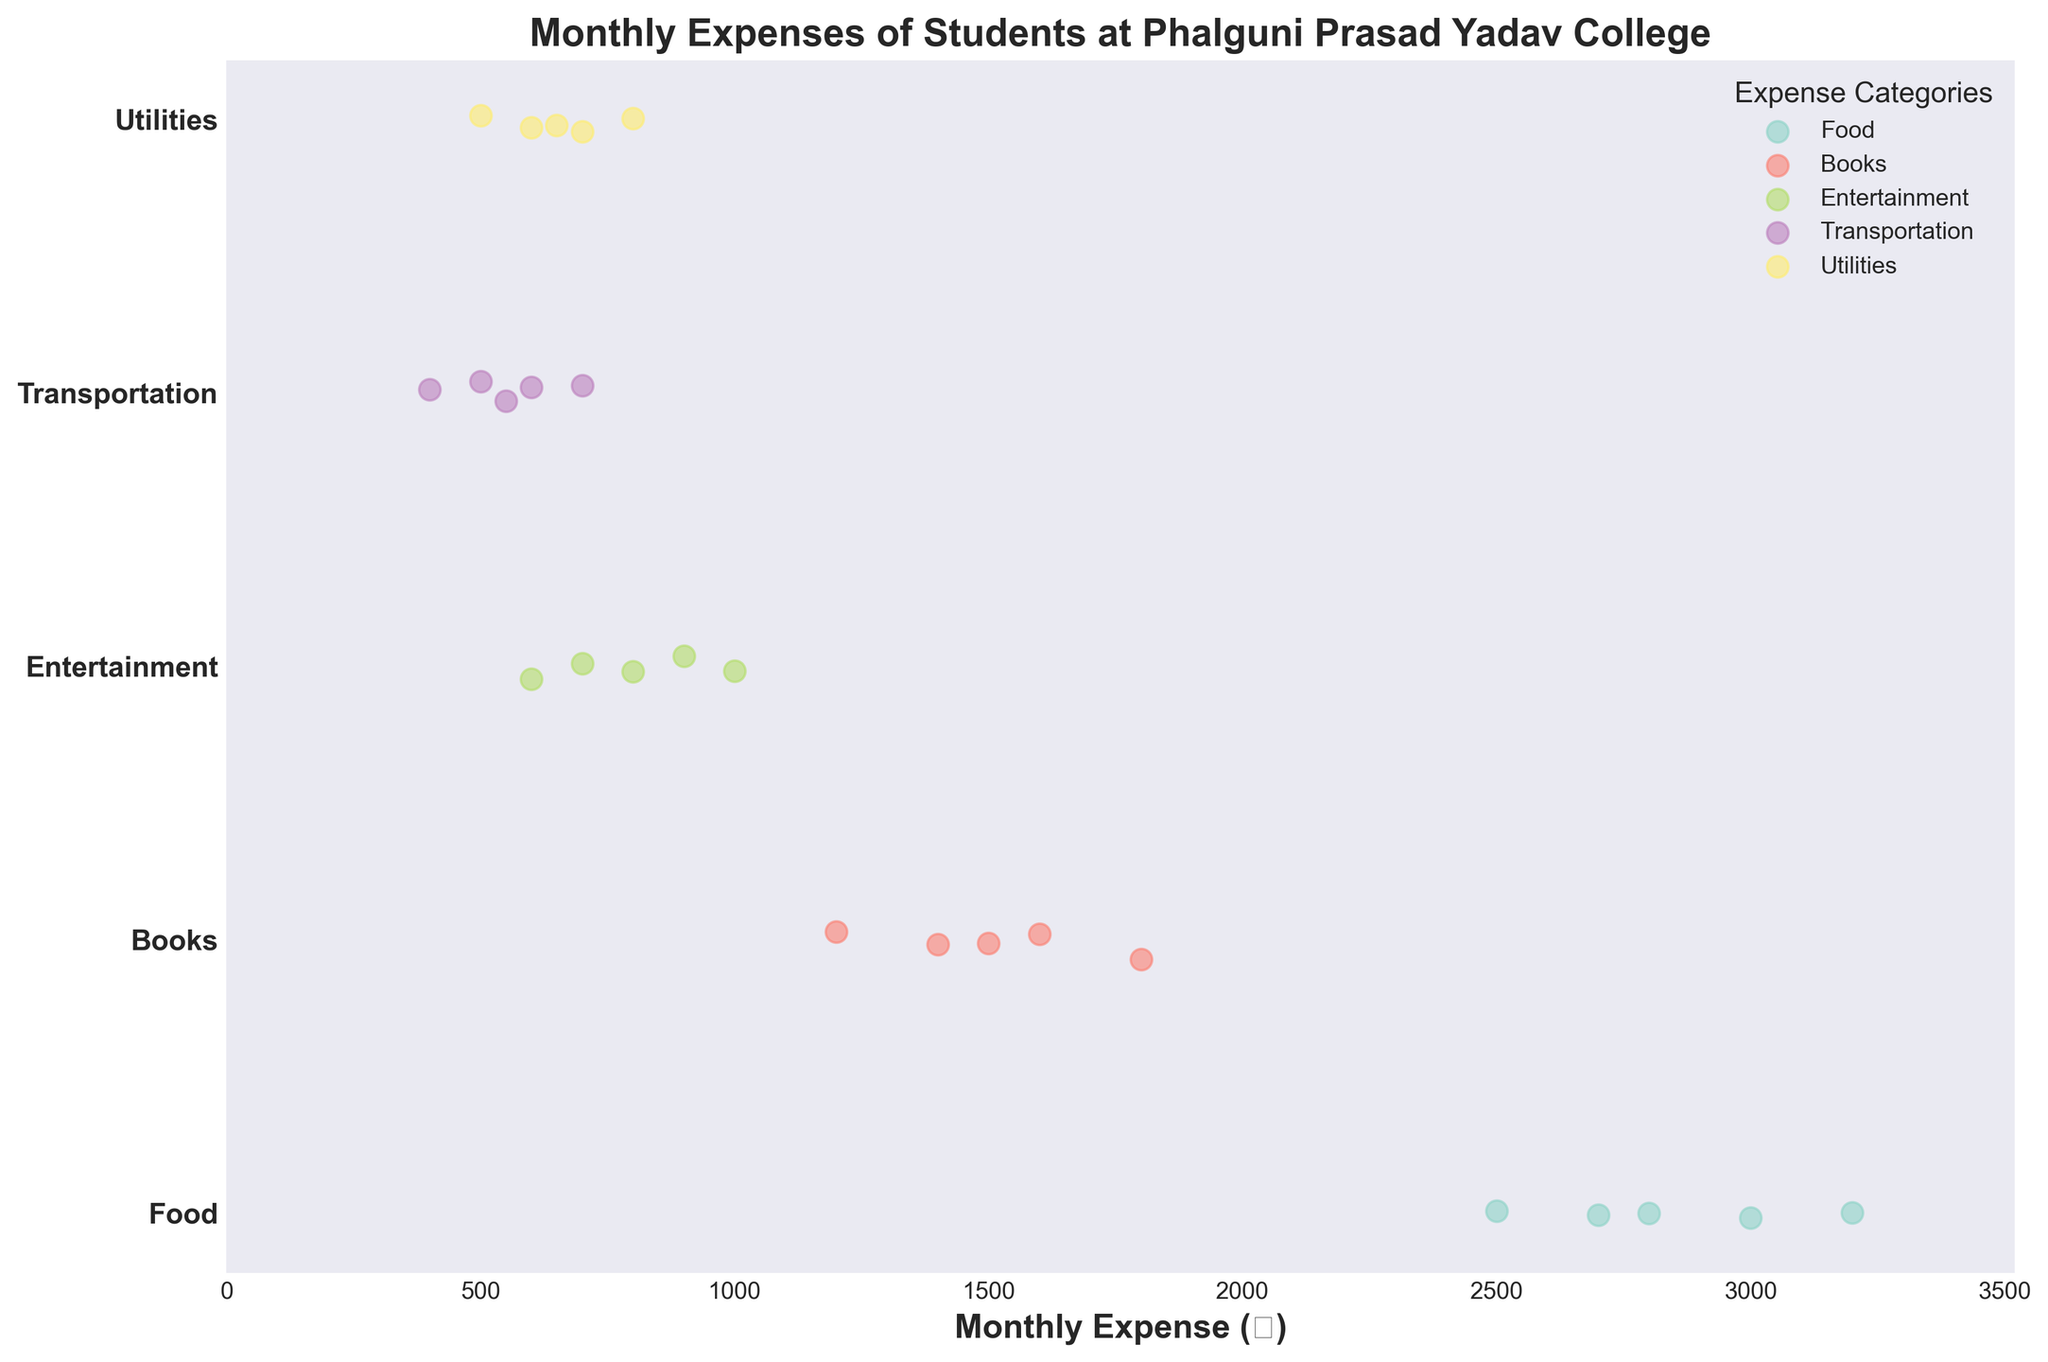What are the different categories of expenses shown in the plot? The different categories of expenses can be identified from the y-axis labels of the plot.
Answer: Food, Books, Entertainment, Transportation, Utilities What does the title of the plot indicate? The title, positioned at the top of the plot, summarises the content by mentioning the subject of the data.
Answer: Monthly Expenses of Students at Phalguni Prasad Yadav College Which category appears to have the highest expenses overall? By observing the x-axis positions of the plotted points, we can see which category's points are generally positioned further to the right, indicating higher expenses.
Answer: Food What's the range of monthly expenses for the Entertainment category? Observing the scatter points for the Entertainment category, we find the minimum and maximum x-axis values for this category. The minimum is around ₹600 and the maximum is around ₹1000.
Answer: ₹600 - ₹1000 How does the average monthly expense for Books compare to that for Transportation? To determine this, we look at the central tendency of the scatter points for these categories. The points for Books are around ₹1500, whereas for Transportation, they're around ₹550-700.
Answer: Higher for Books Which expense category has the smallest range of data points? We can identify the category with the smallest range by comparing the spread (from minimum to maximum value) of the scattered points for each category. Transportation has the smallest range from ₹400 to ₹700.
Answer: Transportation What is the approximate median monthly expense for the Food category? By observing the distribution of points for the Food category, the median would be the middle value. With data points clustered around ₹2800-3200, the median is around ₹2800-3000.
Answer: ₹2800-₹3000 Which category has points that are all below ₹700? Examining the x-axis values, the categories with all points below ₹700 are Transportation and Utilities.
Answer: Transportation, Utilities What is the monthly expense with the highest individual value in the plot? By scanning the farthest right point in any category, it appears one of the Food category points is around ₹3200.
Answer: ₹3200 Which category shows the most varied spending among students? Observing the spread of scatter points across the x-axis, the Food category shows the most varied spending, with points ranging widely around ₹2500 to ₹3200.
Answer: Food 